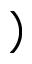Convert formula to latex. <formula><loc_0><loc_0><loc_500><loc_500>)</formula> 